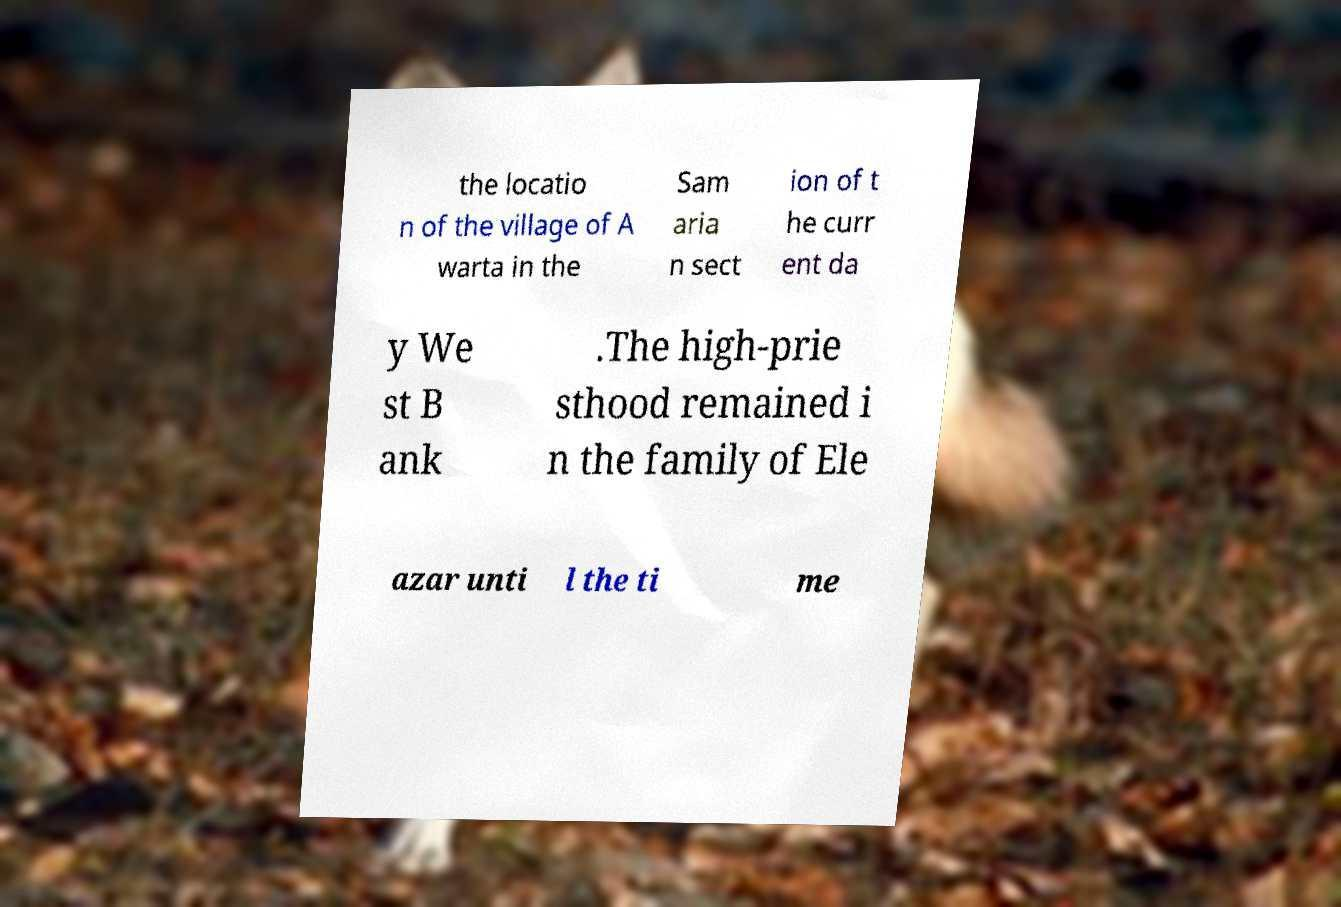For documentation purposes, I need the text within this image transcribed. Could you provide that? the locatio n of the village of A warta in the Sam aria n sect ion of t he curr ent da y We st B ank .The high-prie sthood remained i n the family of Ele azar unti l the ti me 